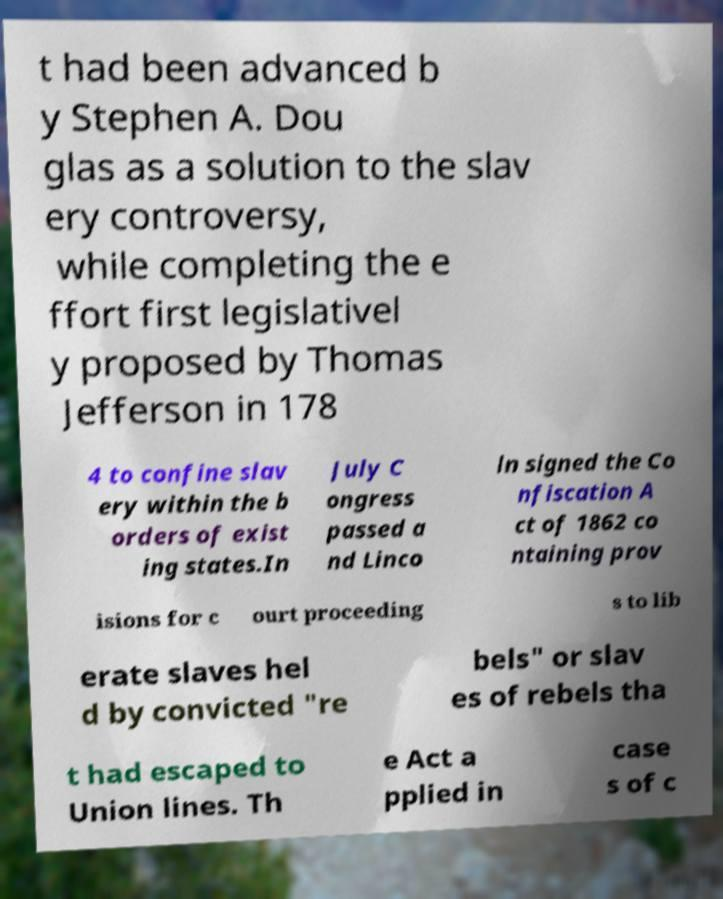Please read and relay the text visible in this image. What does it say? t had been advanced b y Stephen A. Dou glas as a solution to the slav ery controversy, while completing the e ffort first legislativel y proposed by Thomas Jefferson in 178 4 to confine slav ery within the b orders of exist ing states.In July C ongress passed a nd Linco ln signed the Co nfiscation A ct of 1862 co ntaining prov isions for c ourt proceeding s to lib erate slaves hel d by convicted "re bels" or slav es of rebels tha t had escaped to Union lines. Th e Act a pplied in case s of c 